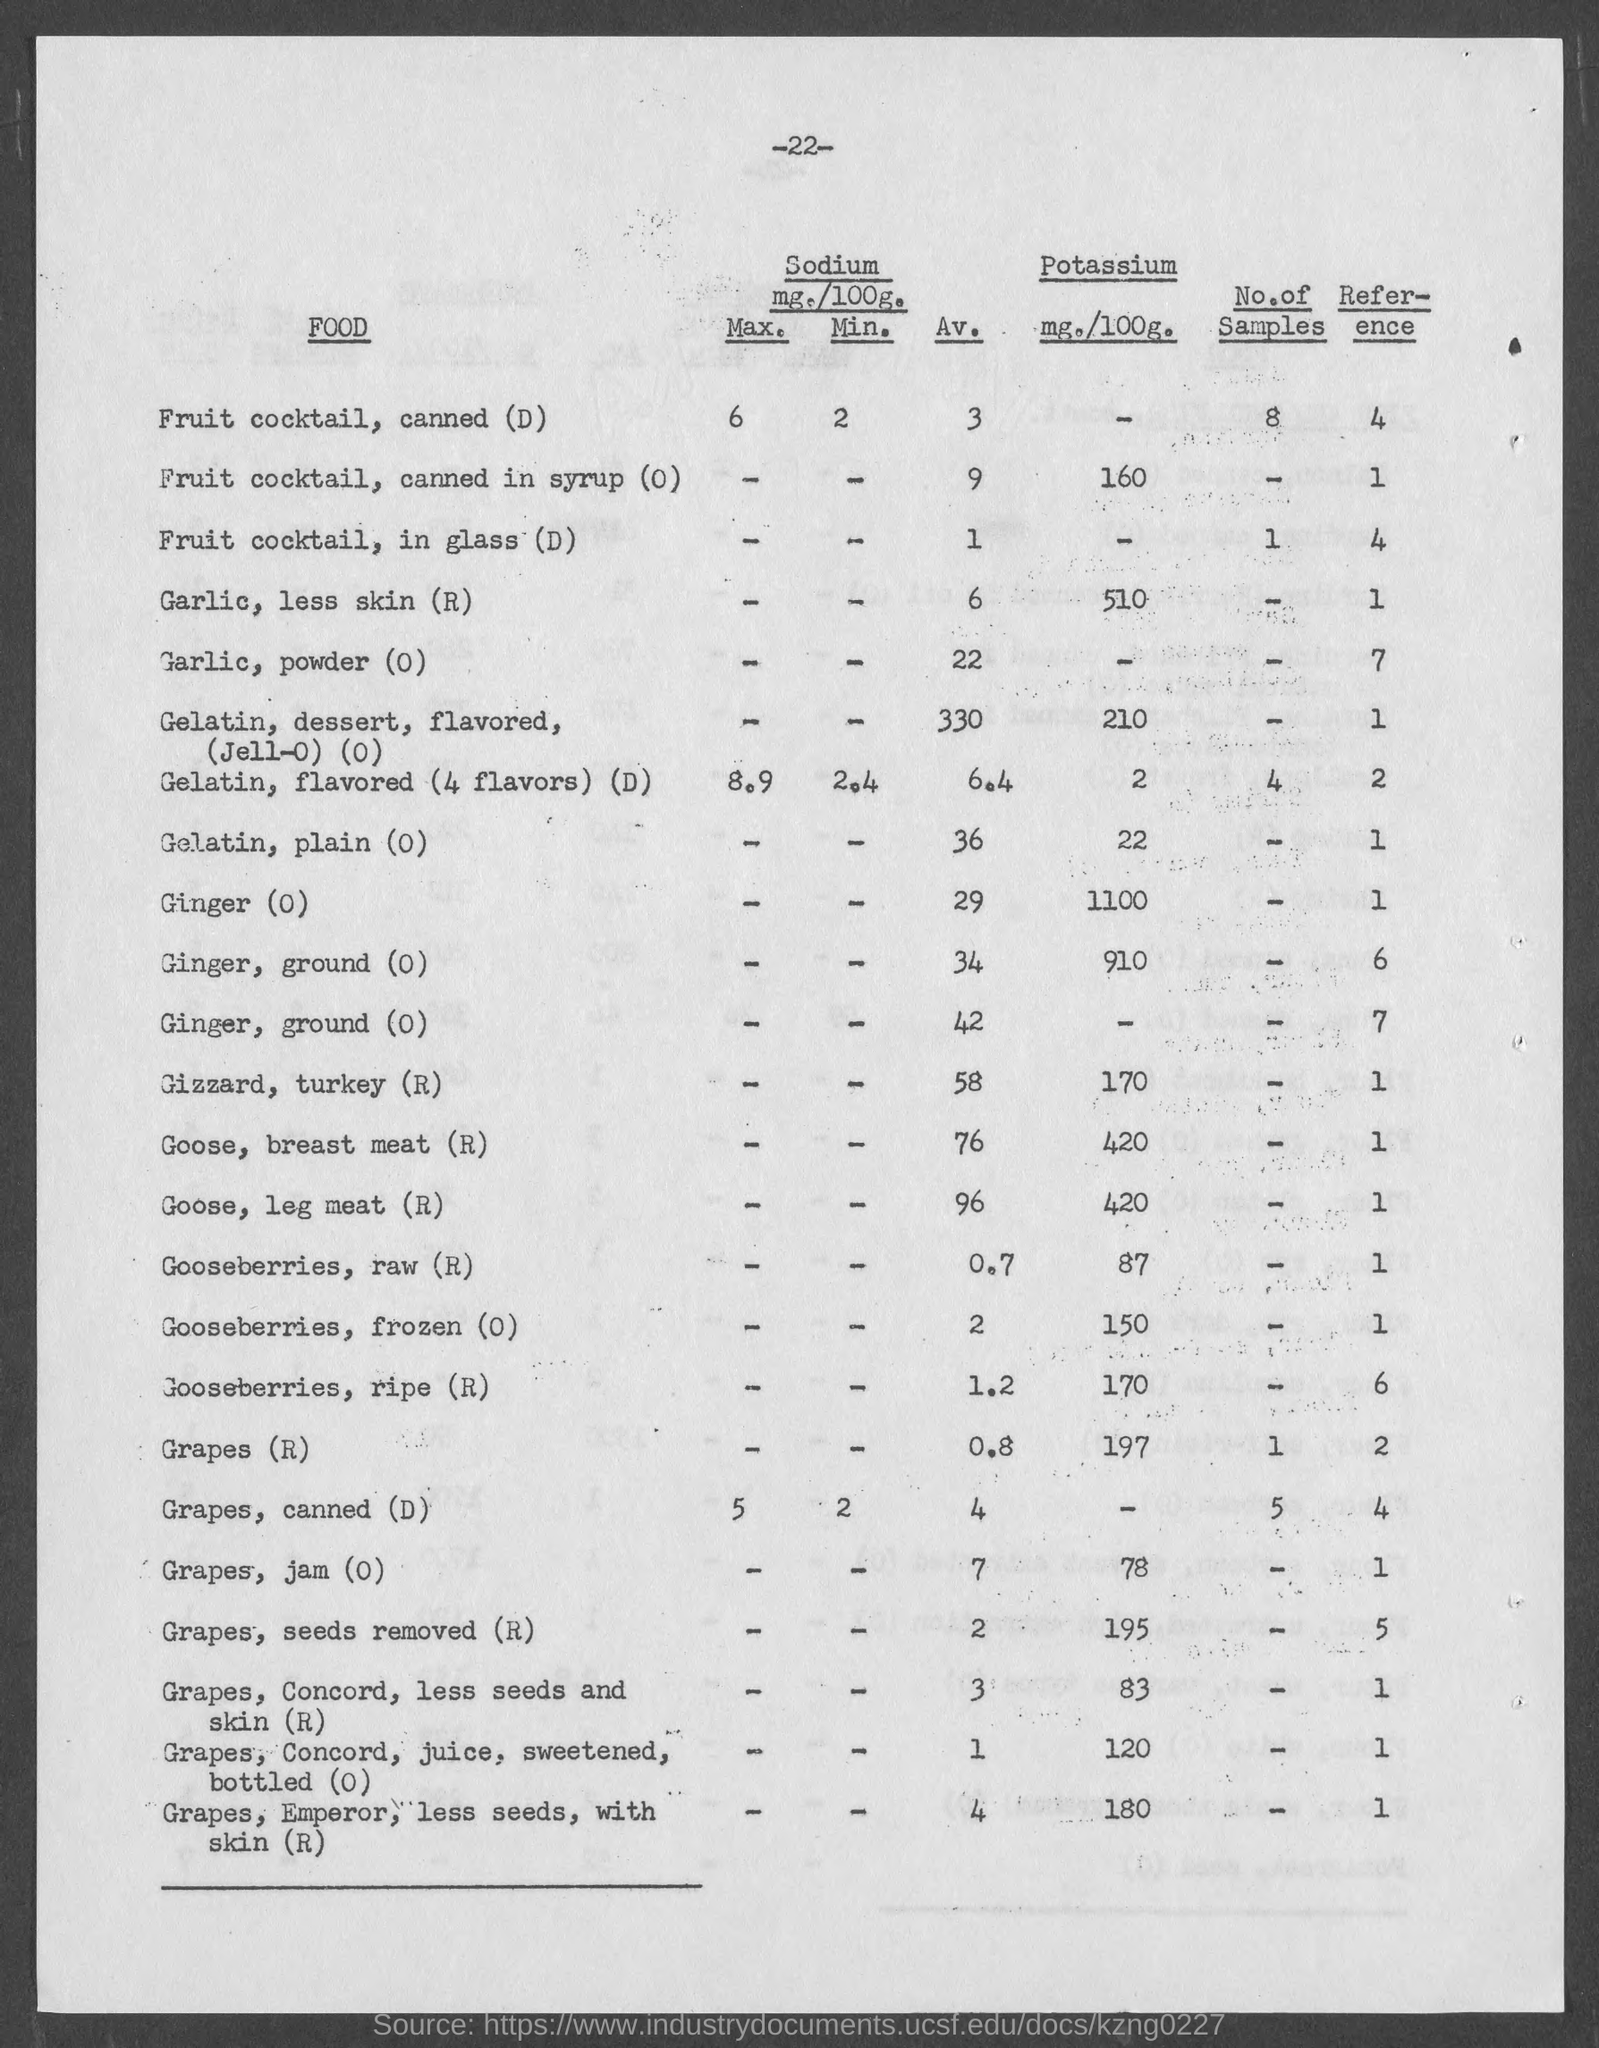List a handful of essential elements in this visual. The amount of potassium in plain gelatin is 22 mg per 100 grams. The amount of potassium in gooseberries, frozen, is 150 milligrams per 100 grams. The amount of potassium in gizzard from a turkey is 170 milligrams per 100 grams. The amount of potassium in garlic, without the skin, is 510 mg per 100 grams. Gooseberries, raw, contain 87 milligrams of potassium per 100 grams. 